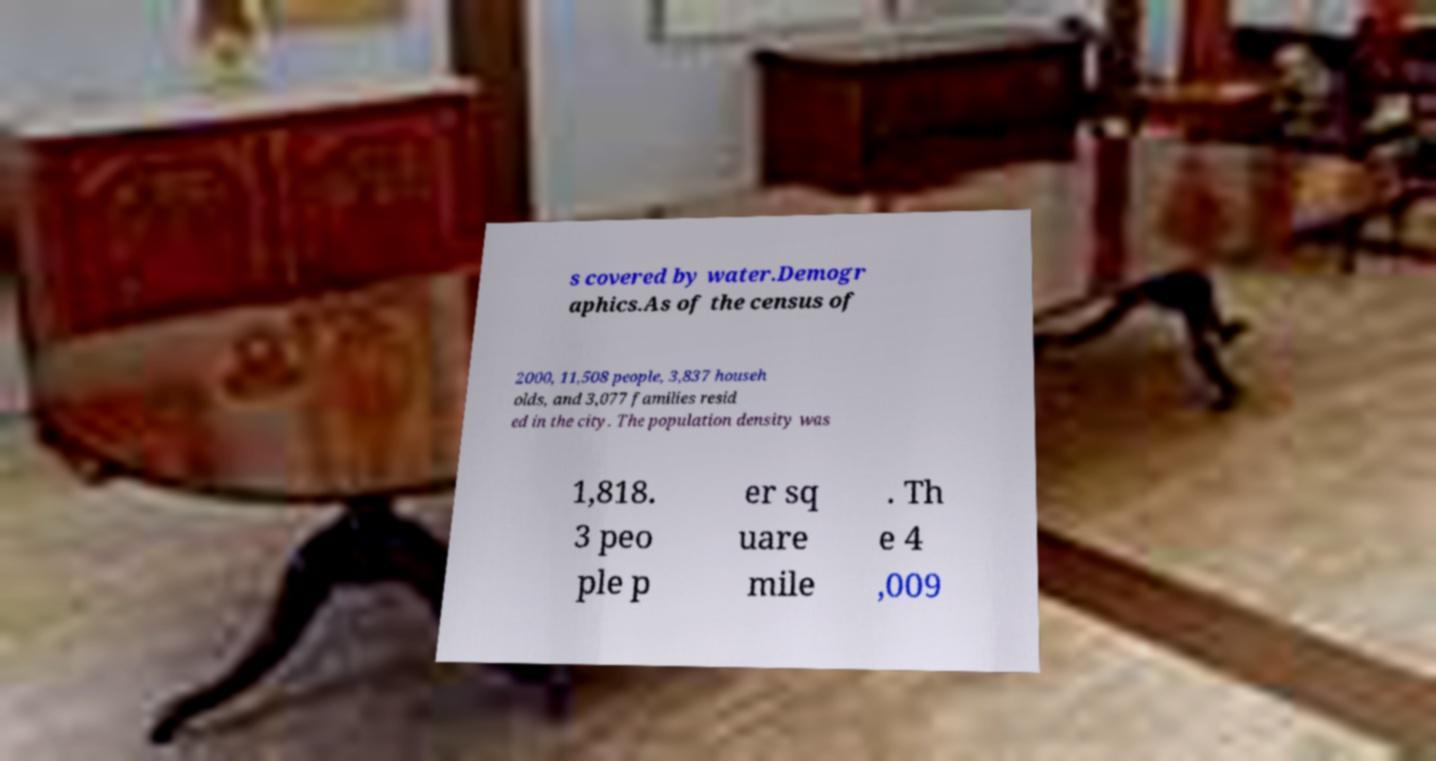Please identify and transcribe the text found in this image. s covered by water.Demogr aphics.As of the census of 2000, 11,508 people, 3,837 househ olds, and 3,077 families resid ed in the city. The population density was 1,818. 3 peo ple p er sq uare mile . Th e 4 ,009 